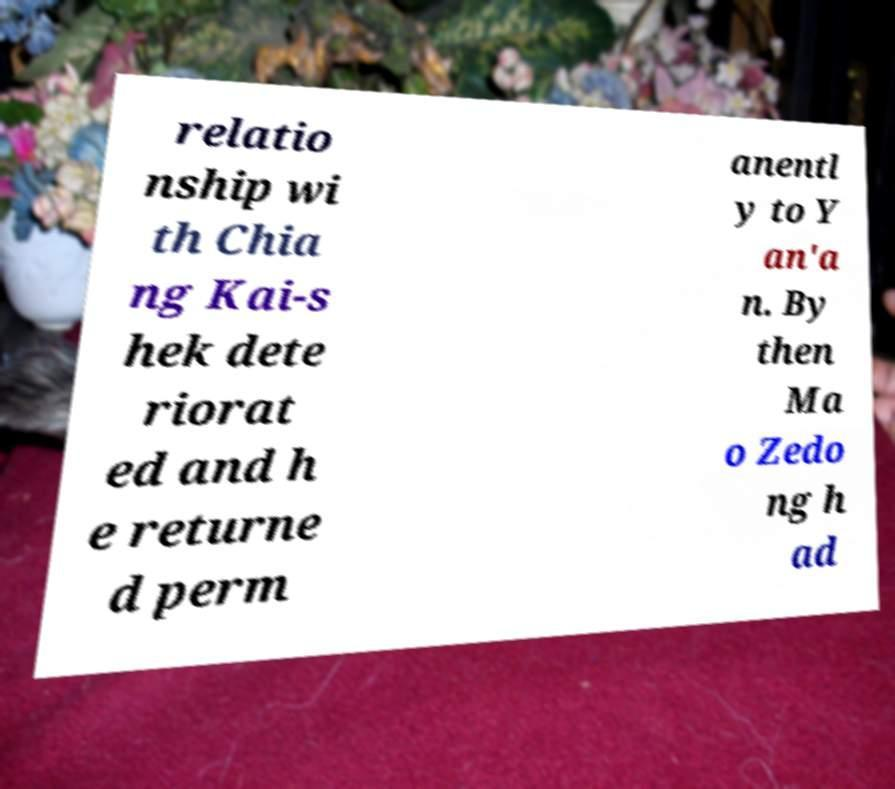I need the written content from this picture converted into text. Can you do that? relatio nship wi th Chia ng Kai-s hek dete riorat ed and h e returne d perm anentl y to Y an'a n. By then Ma o Zedo ng h ad 